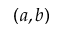<formula> <loc_0><loc_0><loc_500><loc_500>( a , b )</formula> 